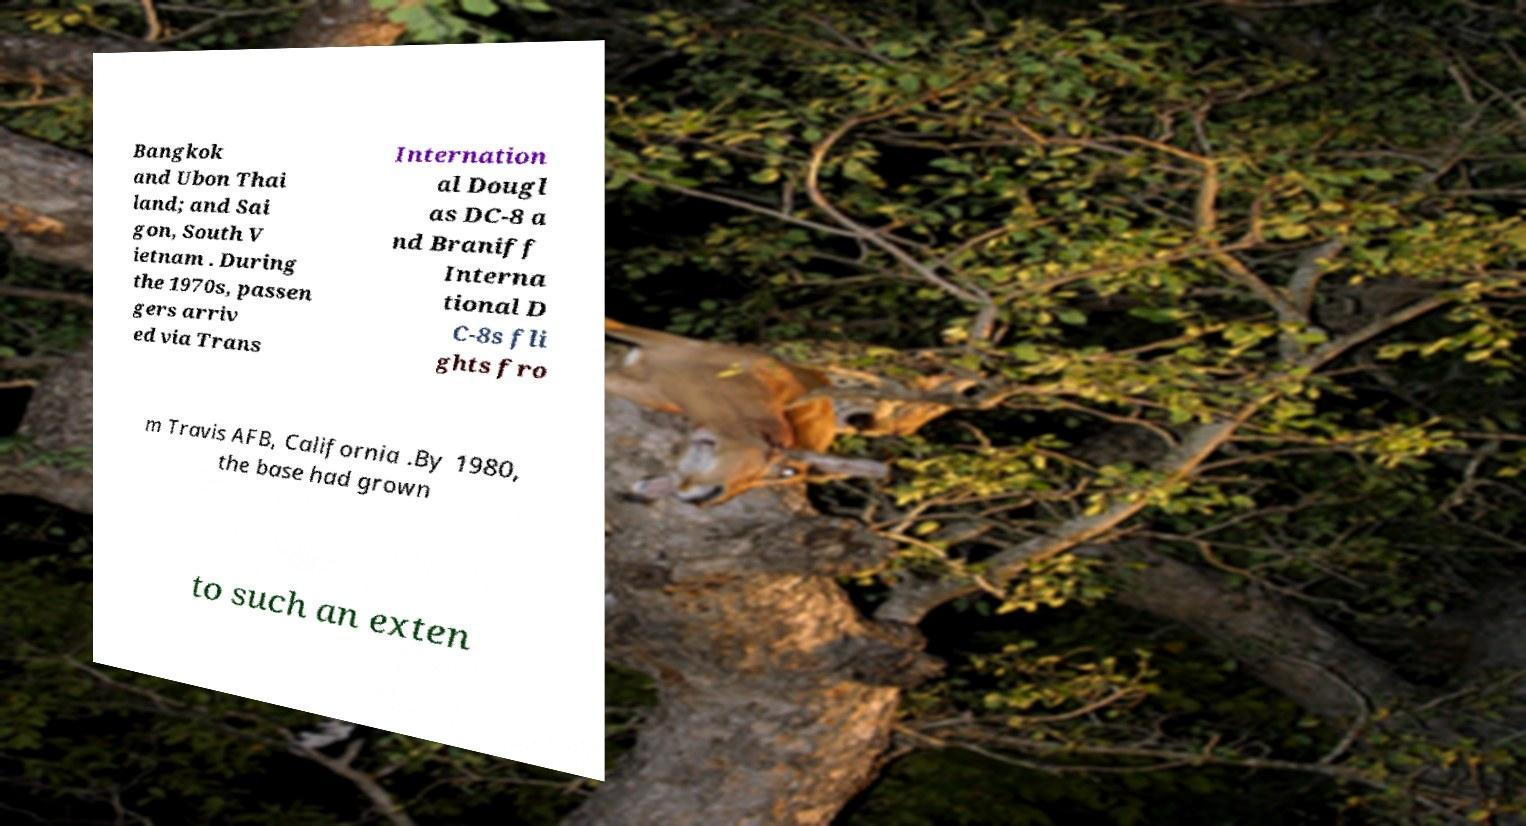Could you extract and type out the text from this image? Bangkok and Ubon Thai land; and Sai gon, South V ietnam . During the 1970s, passen gers arriv ed via Trans Internation al Dougl as DC-8 a nd Braniff Interna tional D C-8s fli ghts fro m Travis AFB, California .By 1980, the base had grown to such an exten 